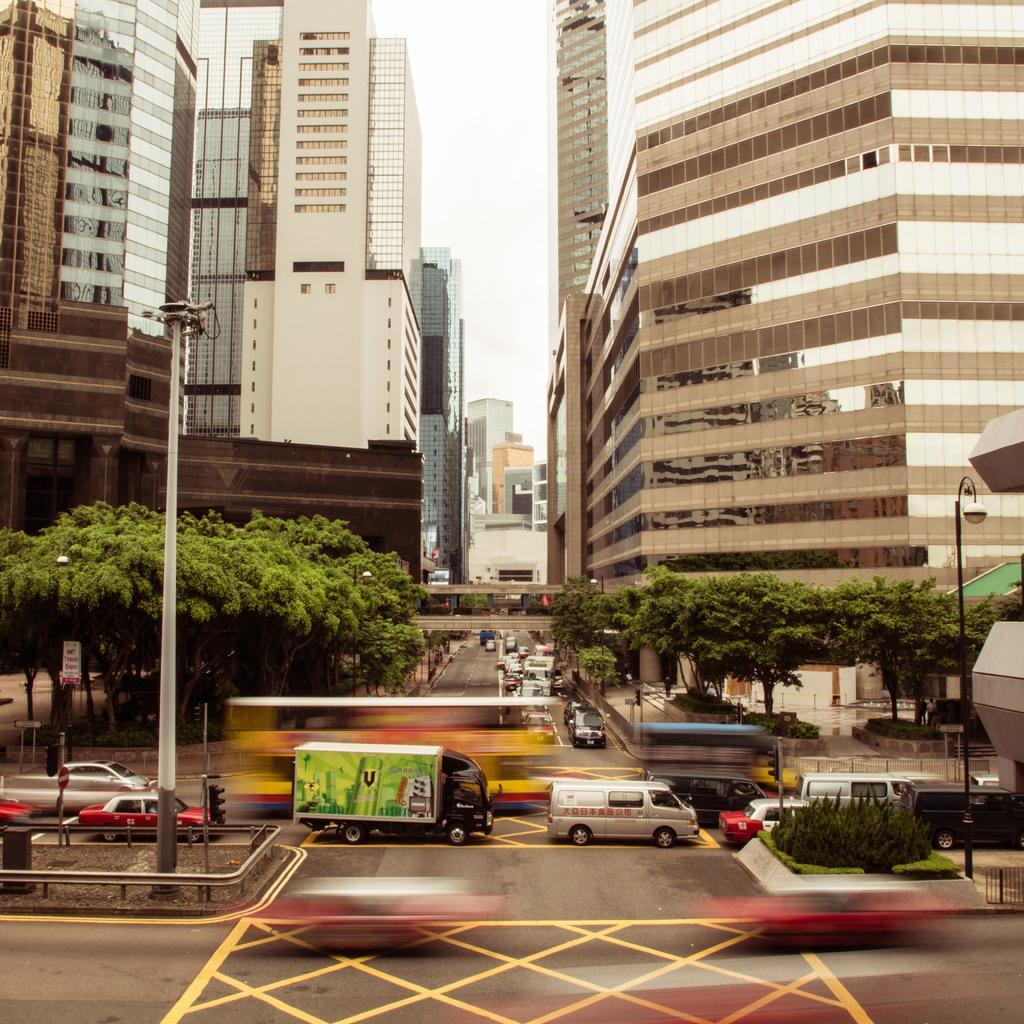In one or two sentences, can you explain what this image depicts? In this picture I can see vehicles on the road, there are poles, lights, trees, buildings, and in the background there is sky. 